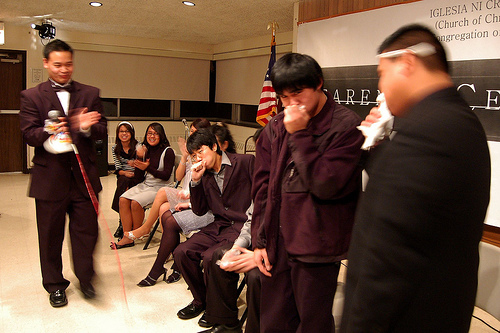<image>
Can you confirm if the flag is to the right of the window? Yes. From this viewpoint, the flag is positioned to the right side relative to the window. 